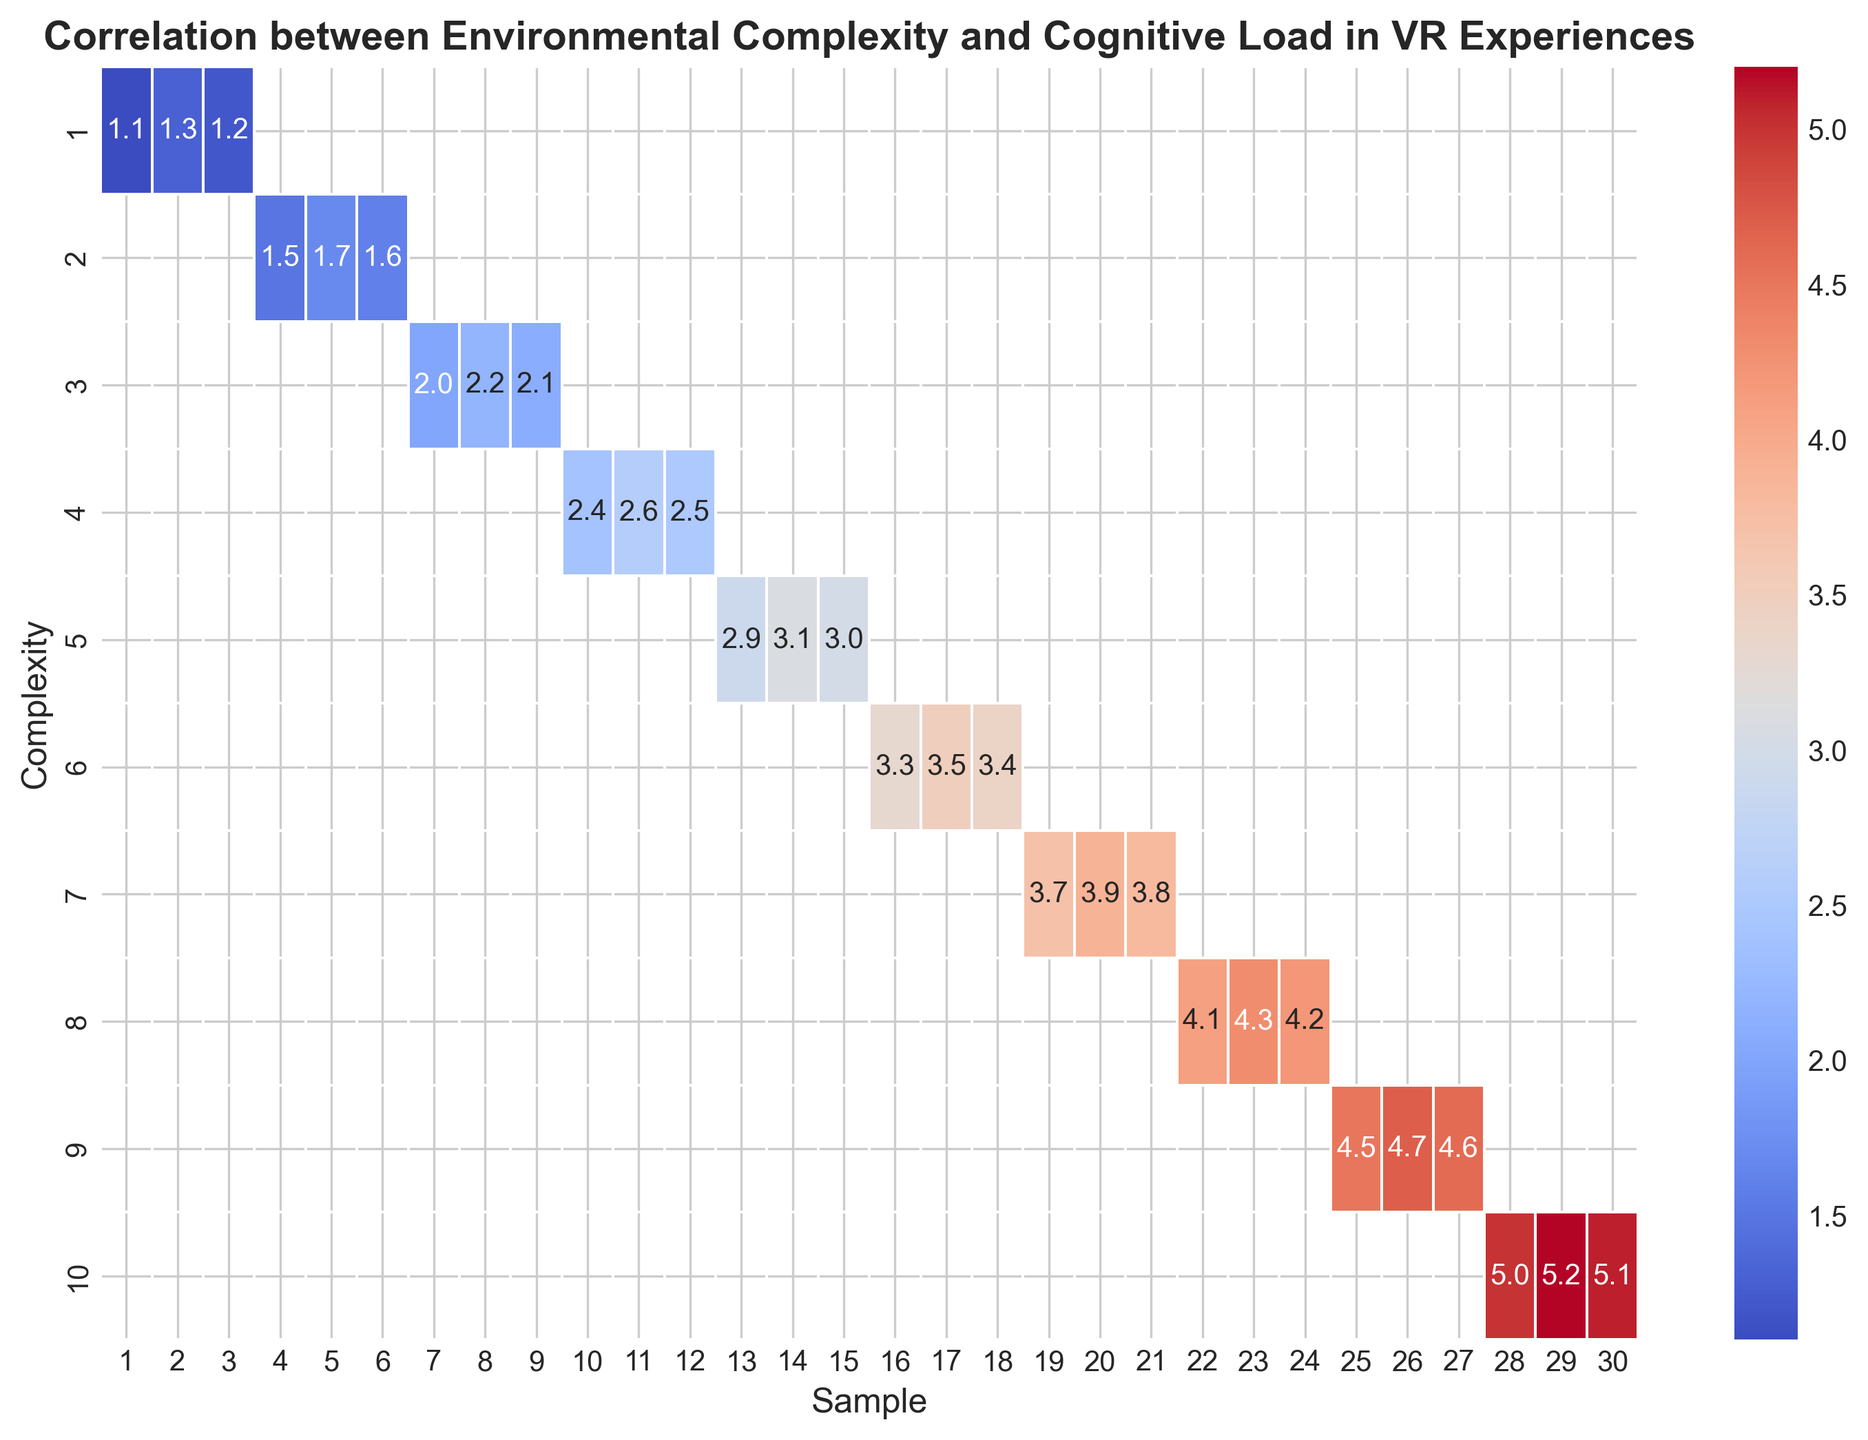What range of cognitive load values is observed at the highest environmental complexity level? The heatmap shows the cognitive load values on the color scale and annotates the numeric values. For the highest complexity level (10), the cognitive load values are 5.0, 5.1, and 5.2.
Answer: 5.0 to 5.2 Which complexity level shows the steepest increase in cognitive load compared to its preceding level? By visually inspecting the change in cognitive load values as complexity increases, the largest jump occurs between complexity levels 9 and 10, where the load increases from the range of 4.5-4.7 to the range of 5.0-5.2.
Answer: 10 What is the average cognitive load for environmental complexity levels 5 and 6? At complexity level 5, the cognitive load values are 2.9, 3.0, and 3.1. At level 6, the values are 3.3, 3.4, and 3.5. The average for level 5 is (2.9 + 3.0 + 3.1) / 3 = 3.0. The average for level 6 is (3.3 + 3.4 + 3.5) / 3 = 3.4.
Answer: 3.0 and 3.4 Which color represents the highest cognitive load, and what is its corresponding complexity level and value? The highest cognitive load value annotated in the heatmap is 5.2, corresponding to the darkest red shade, signifying the highest load, at complexity level 10.
Answer: Darkest red, 10, 5.2 Is there a clear linear relationship between environmental complexity and cognitive load? Visually examining the heatmap, there is a noticeable trend where cognitive load generally increases as environmental complexity increases. Each step up in complexity tends to show a higher range of cognitive load values.
Answer: Yes 